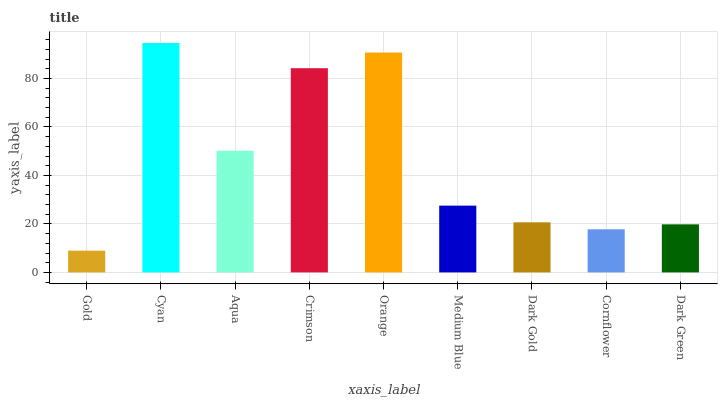Is Gold the minimum?
Answer yes or no. Yes. Is Cyan the maximum?
Answer yes or no. Yes. Is Aqua the minimum?
Answer yes or no. No. Is Aqua the maximum?
Answer yes or no. No. Is Cyan greater than Aqua?
Answer yes or no. Yes. Is Aqua less than Cyan?
Answer yes or no. Yes. Is Aqua greater than Cyan?
Answer yes or no. No. Is Cyan less than Aqua?
Answer yes or no. No. Is Medium Blue the high median?
Answer yes or no. Yes. Is Medium Blue the low median?
Answer yes or no. Yes. Is Cyan the high median?
Answer yes or no. No. Is Dark Gold the low median?
Answer yes or no. No. 